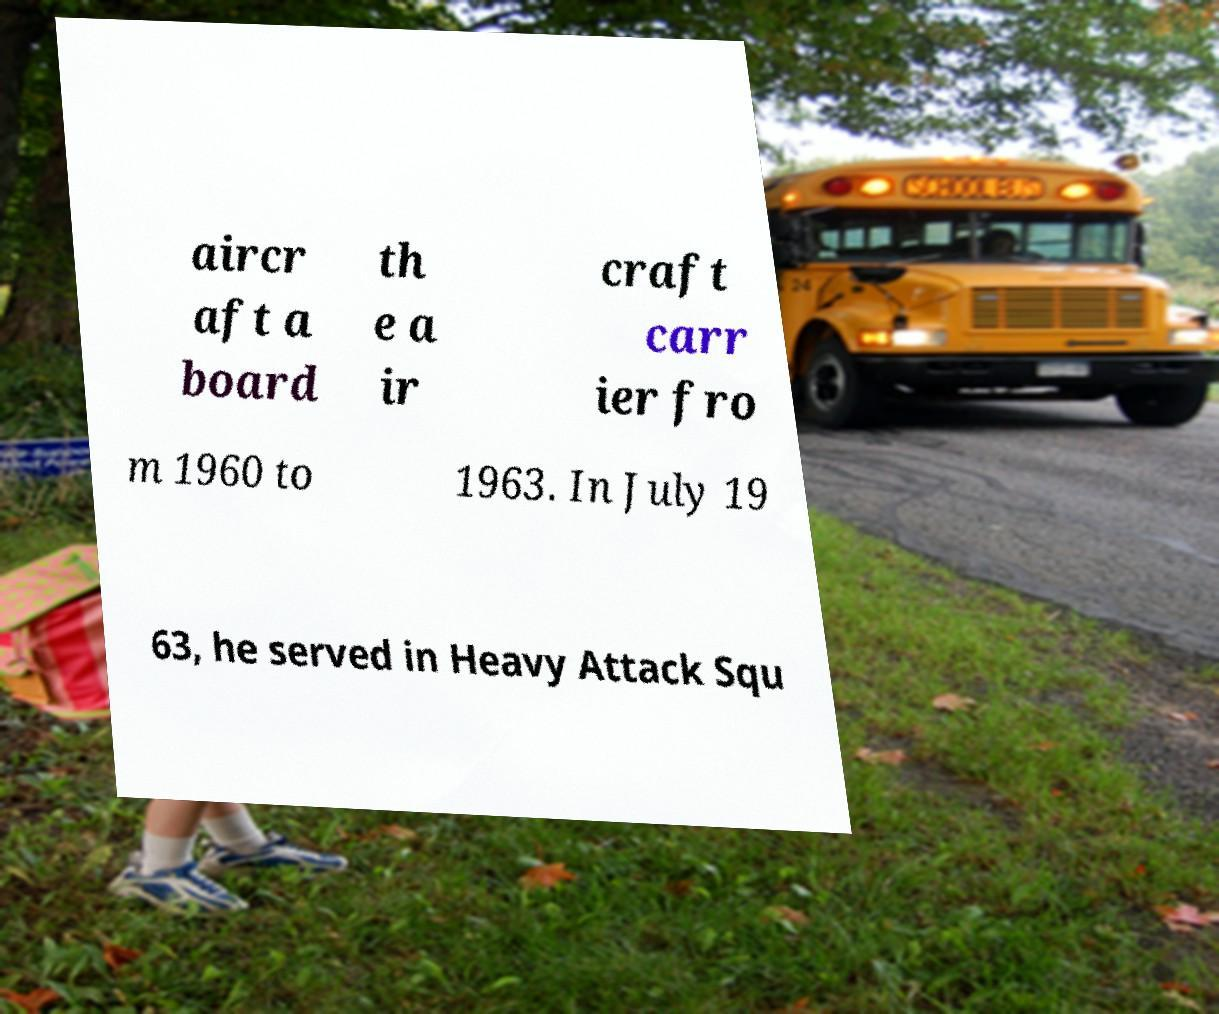Please identify and transcribe the text found in this image. aircr aft a board th e a ir craft carr ier fro m 1960 to 1963. In July 19 63, he served in Heavy Attack Squ 